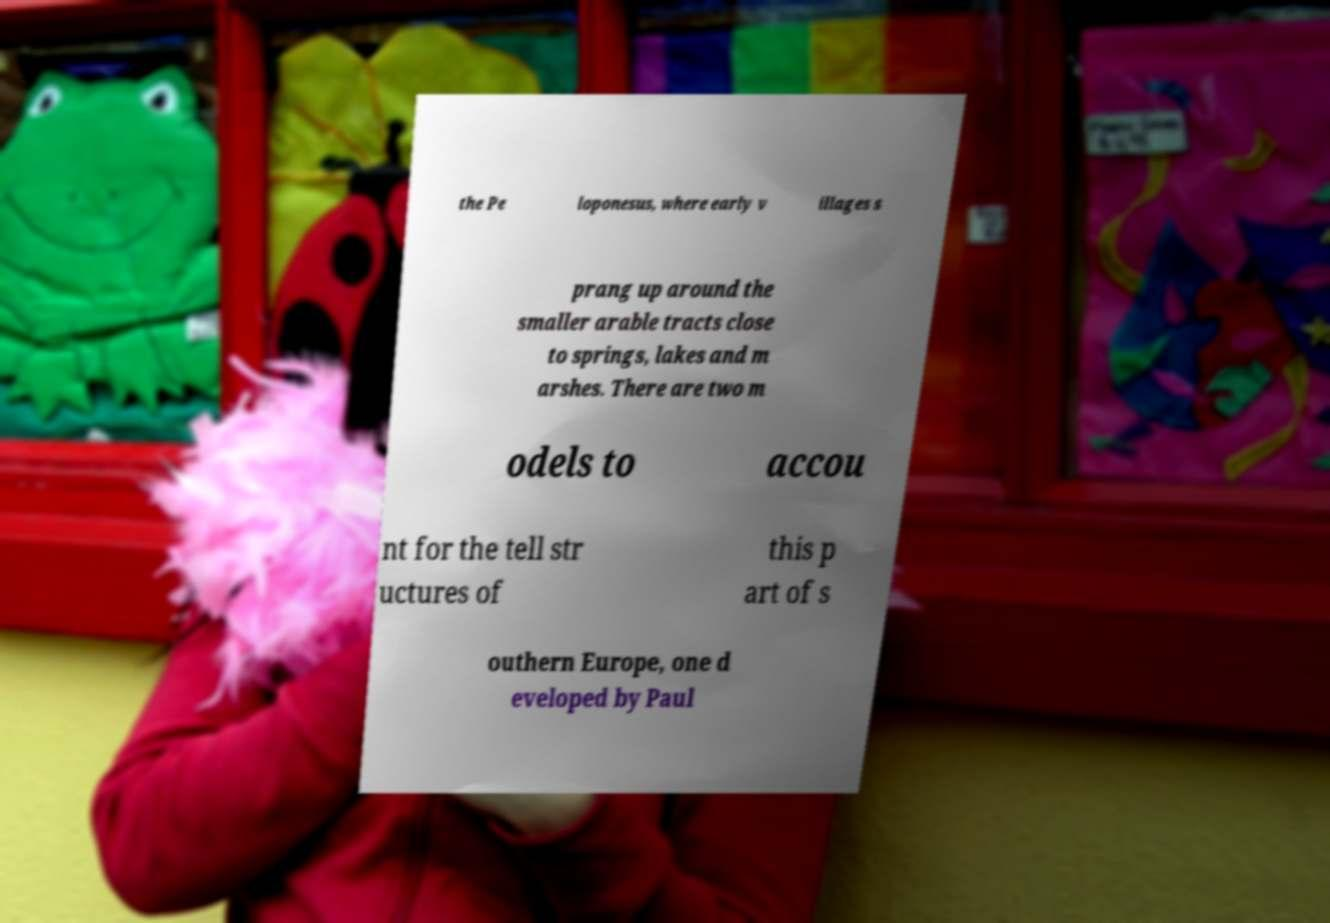Can you accurately transcribe the text from the provided image for me? the Pe loponesus, where early v illages s prang up around the smaller arable tracts close to springs, lakes and m arshes. There are two m odels to accou nt for the tell str uctures of this p art of s outhern Europe, one d eveloped by Paul 